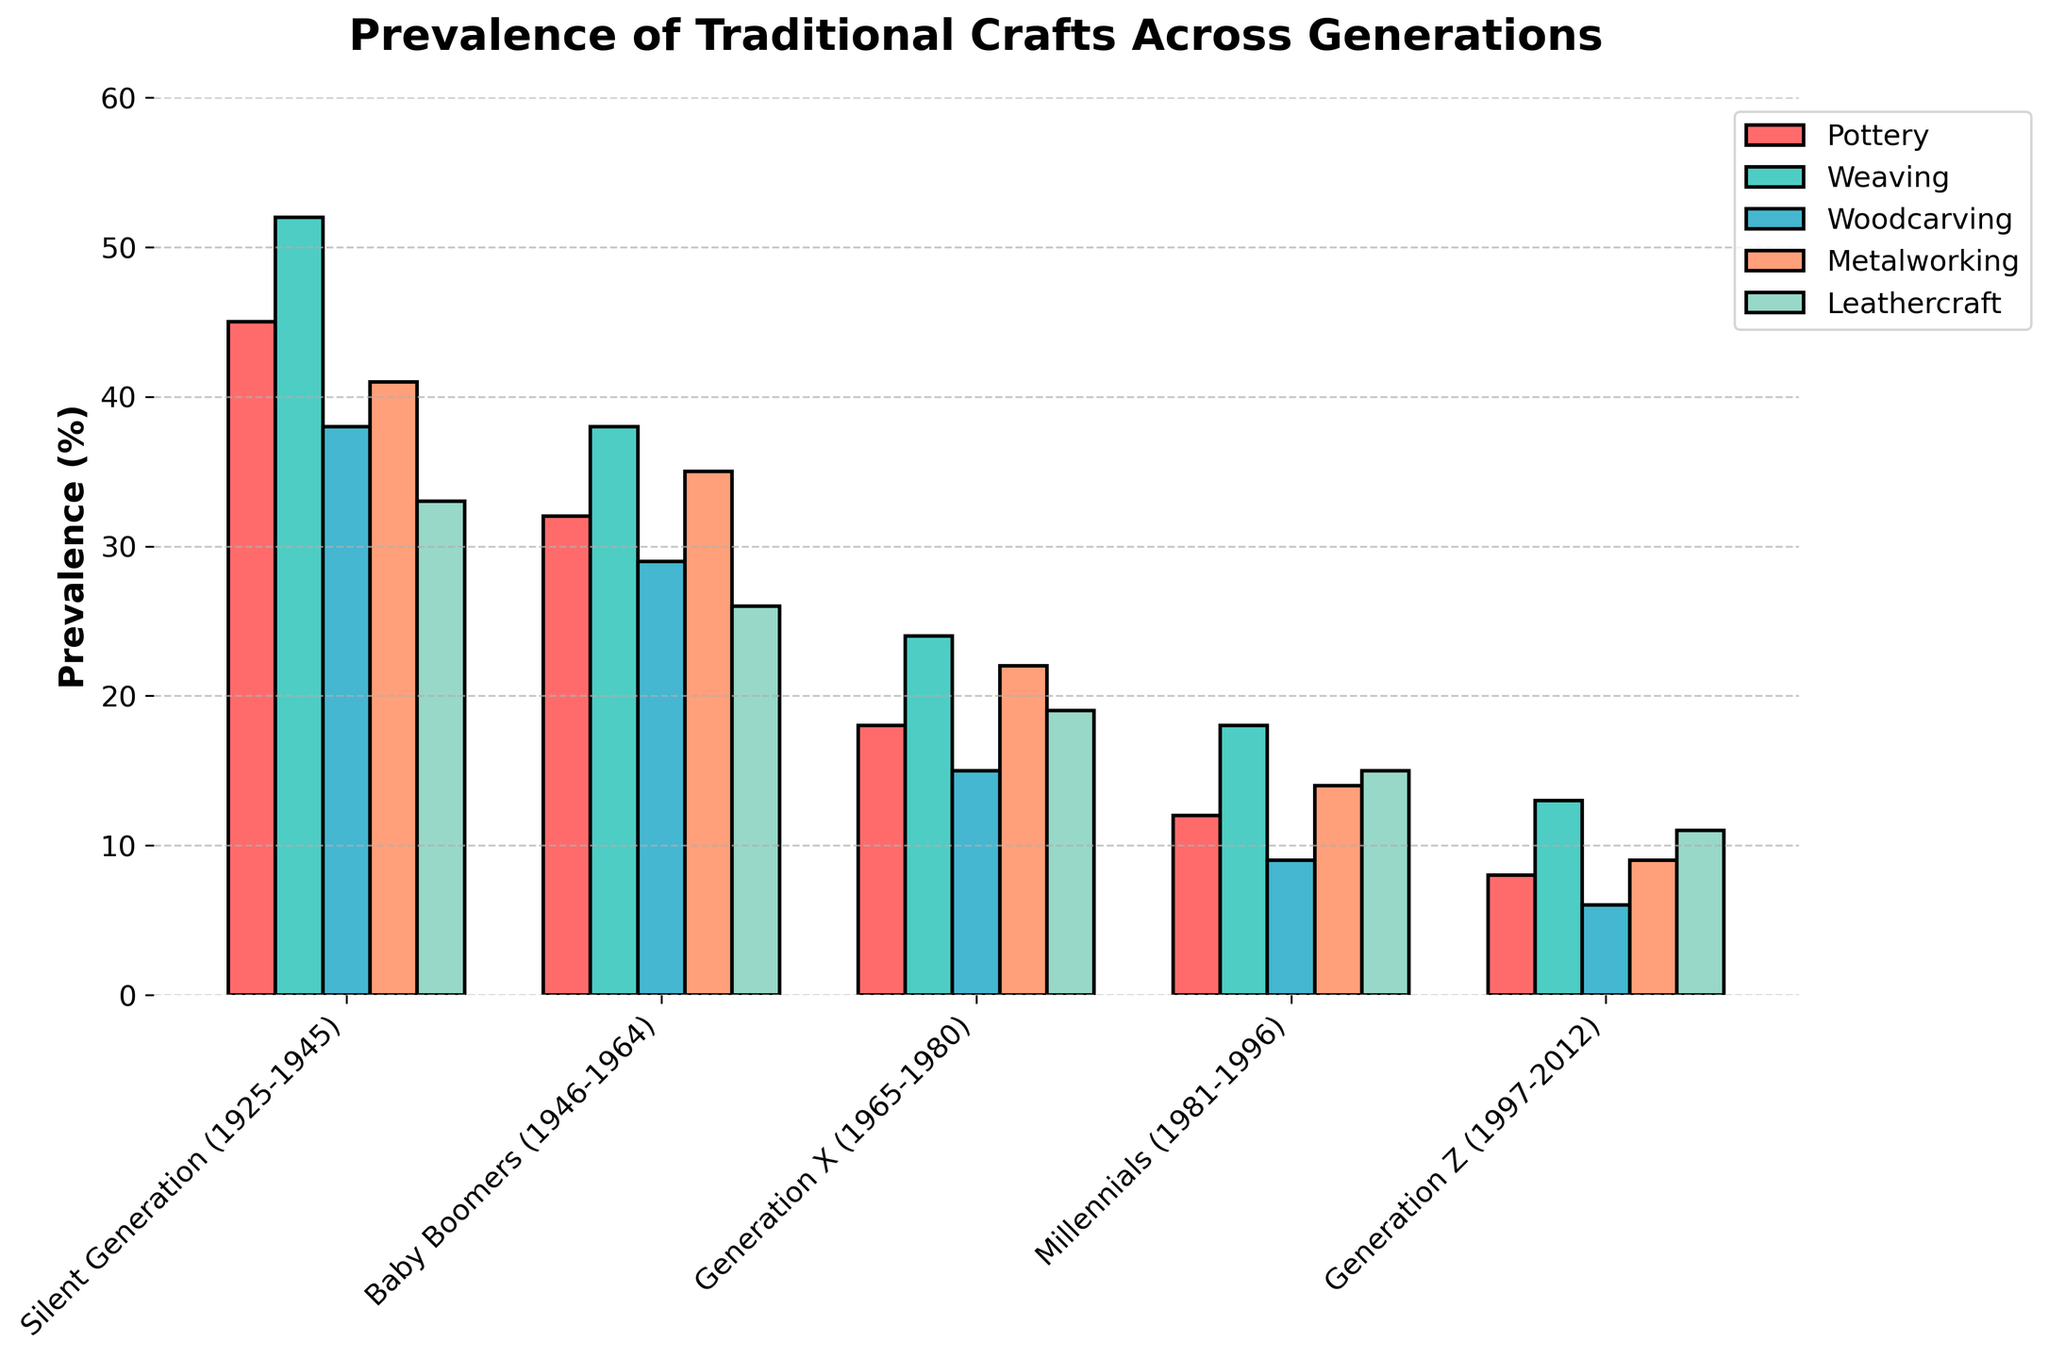What's the average prevalence of Woodcarving across all generations? The Woodcarving percentages across generations are 38, 29, 15, 9, and 6. Summing these gives 97, and dividing by the number of data points (5) gives the average.
Answer: 19.4% Which generation has the highest prevalence of Weaving? By observing the bar heights and the values for Weaving: Silent Generation (52%), Baby Boomers (38%), Generation X (24%), Millennials (18%), and Generation Z (13%), the Silent Generation has the highest value.
Answer: Silent Generation Is the prevalence of Pottery higher in Generation X or Millennials? By comparing the bar heights and percentages for Pottery: Generation X (18%) and Millennials (12%), Generation X has a higher prevalence.
Answer: Generation X Which traditional craft has the lowest prevalence in Generation Z? By comparing the bar heights and percentages for Generation Z: Pottery (8%), Weaving (13%), Woodcarving (6%), Metalworking (9%), and Leathercraft (11%), Woodcarving has the lowest value.
Answer: Woodcarving What's the total prevalence of Metalworking from Baby Boomers to Generation Z? The percentages for Metalworking across these generations are 35%, 22%, 14%, and 9%. Summing these gives 35 + 22 + 14 + 9 = 80.
Answer: 80% How does the prevalence of Leathercraft in Baby Boomers compare to Millennials? By comparing the values for Leathercraft: Baby Boomers (26%) and Millennials (15%), Baby Boomers have a higher prevalence.
Answer: Baby Boomers Which traditional craft shows the steepest decline in prevalence from the Silent Generation to Generation Z? Calculate the difference in prevalence for each craft between these generations: Pottery decreases by 45-8=37%, Weaving by 52-13=39%, Woodcarving by 38-6=32%, Metalworking by 41-9=32%, and Leathercraft by 33-11=22%. Weaving shows the steepest decline.
Answer: Weaving What's the ratio of the prevalence of Pottery in the Silent Generation to Generation Z? The percentages are 45% for the Silent Generation and 8% for Generation Z. The ratio is 45/8.
Answer: 5.625 Which generation shows the least variation in the prevalence of the five crafts? Variations can be measured by the range (max-min) for each generation: Silent Generation (52-33=19), Baby Boomers (38-26=12), Generation X (24-15=9), Millennials (18-9=9), Generation Z (13-6=7). Generation Z shows the least variation.
Answer: Generation Z Between which two crafts is the difference in prevalence the smallest for Generation Z? By comparing the values for Generation Z: Pottery (8%), Weaving (13%), Woodcarving (6%), Metalworking (9%), and Leathercraft (11%), the smallest difference is between Metalworking and Leathercraft (11-9=2).
Answer: Metalworking and Leathercraft 